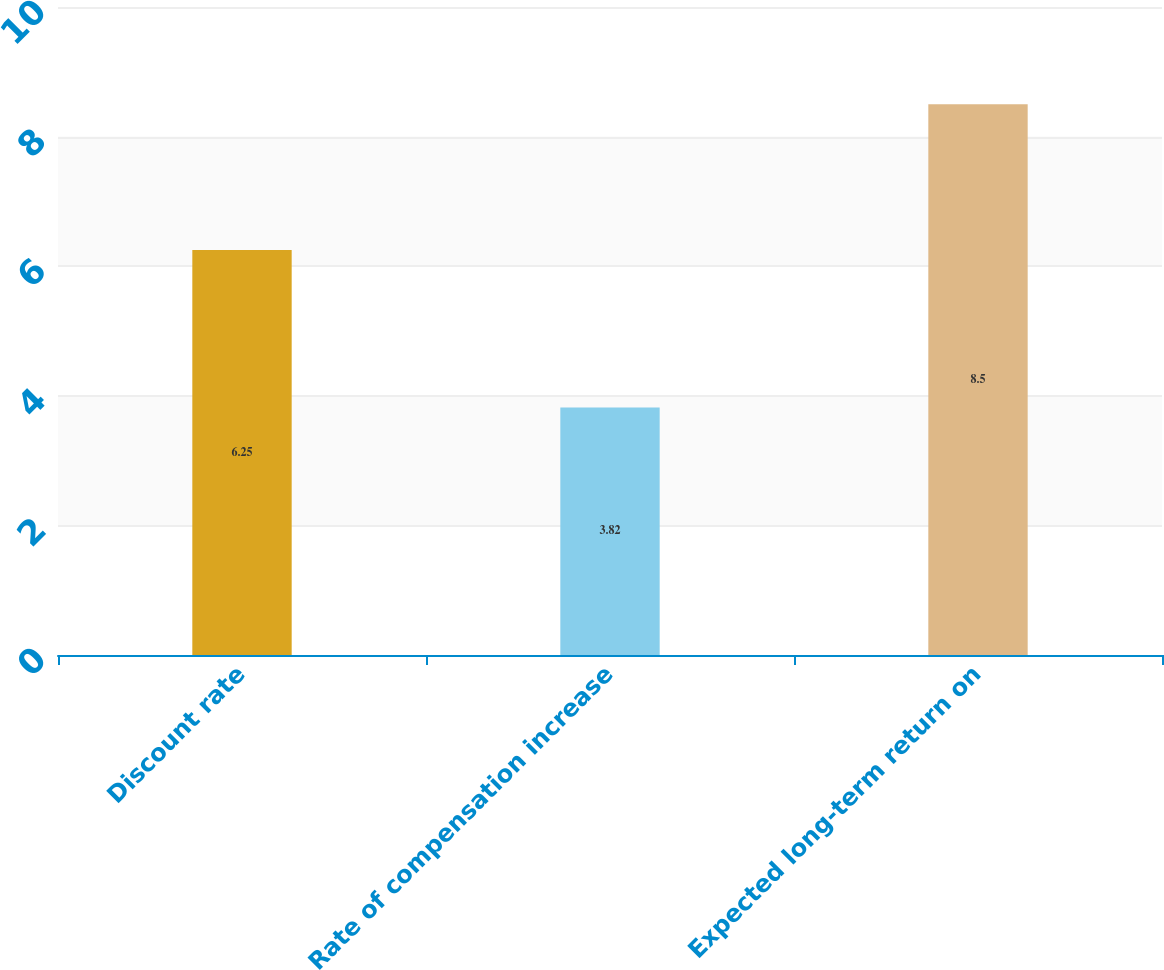Convert chart to OTSL. <chart><loc_0><loc_0><loc_500><loc_500><bar_chart><fcel>Discount rate<fcel>Rate of compensation increase<fcel>Expected long-term return on<nl><fcel>6.25<fcel>3.82<fcel>8.5<nl></chart> 